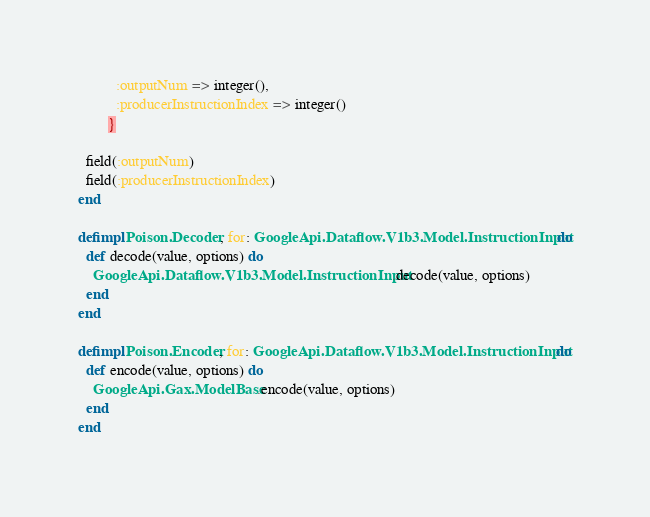Convert code to text. <code><loc_0><loc_0><loc_500><loc_500><_Elixir_>          :outputNum => integer(),
          :producerInstructionIndex => integer()
        }

  field(:outputNum)
  field(:producerInstructionIndex)
end

defimpl Poison.Decoder, for: GoogleApi.Dataflow.V1b3.Model.InstructionInput do
  def decode(value, options) do
    GoogleApi.Dataflow.V1b3.Model.InstructionInput.decode(value, options)
  end
end

defimpl Poison.Encoder, for: GoogleApi.Dataflow.V1b3.Model.InstructionInput do
  def encode(value, options) do
    GoogleApi.Gax.ModelBase.encode(value, options)
  end
end
</code> 